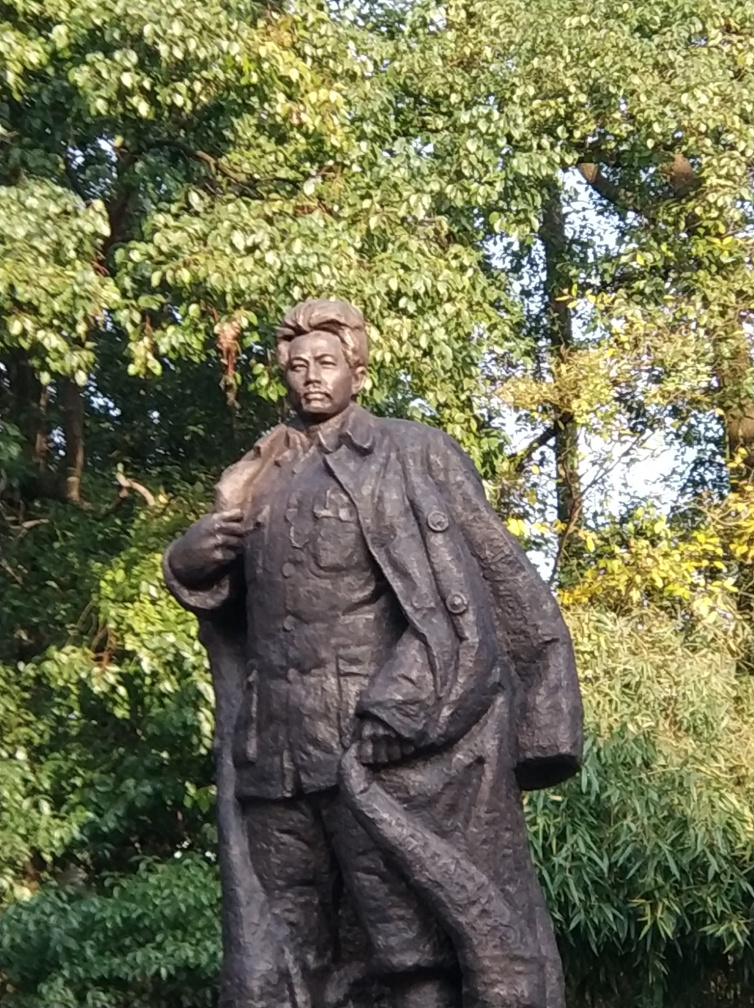Is there a slight motion blur present in the image?
A. No
B. Yes
Answer with the option's letter from the given choices directly.
 B. 